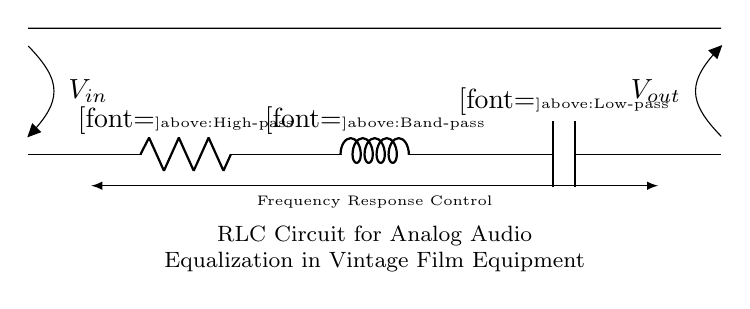What type of circuit is depicted? The circuit is an RLC circuit, which is characterized by the presence of resistors, inductors, and capacitors working together.
Answer: RLC circuit What does the R component represent? The R in the circuit stands for resistance, and it is typically used to filter high-frequency signals in audio applications.
Answer: High-pass What does the L component represent in this context? The L component in this circuit represents inductance, which allows certain frequencies to pass while attenuating others, serving as a band-pass filter in this configuration.
Answer: Band-pass What does the C component indicate? The C component indicates capacitance, which is primarily used for filtering low-frequency signals in audio systems, functioning as a low-pass filter.
Answer: Low-pass What is the primary function of this RLC circuit? The primary function of this RLC circuit is to provide frequency response control to adjust audio signals for vintage film equipment.
Answer: Audio equalization How does the arrangement of R, L, and C affect sound frequencies? The arrangement of R, L, and C provides a combined effect of filtering, where R allows high frequencies, L allows a specific band of frequencies, and C allows low frequencies, thereby shaping the overall sound.
Answer: Frequency response control What does the 'V_in' and 'V_out' signify? 'V_in' represents the input voltage applied to the circuit while 'V_out' indicates the output voltage, demonstrating the effect of the RLC filtering on the original signal.
Answer: Input and output voltages 